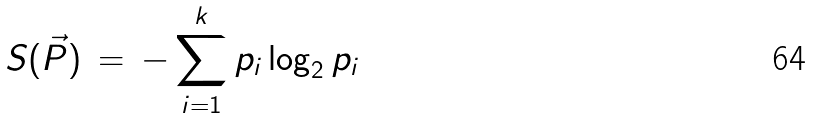<formula> <loc_0><loc_0><loc_500><loc_500>S ( \vec { P } ) \, = \, - \sum _ { i = 1 } ^ { k } p _ { i } \log _ { 2 } p _ { i }</formula> 